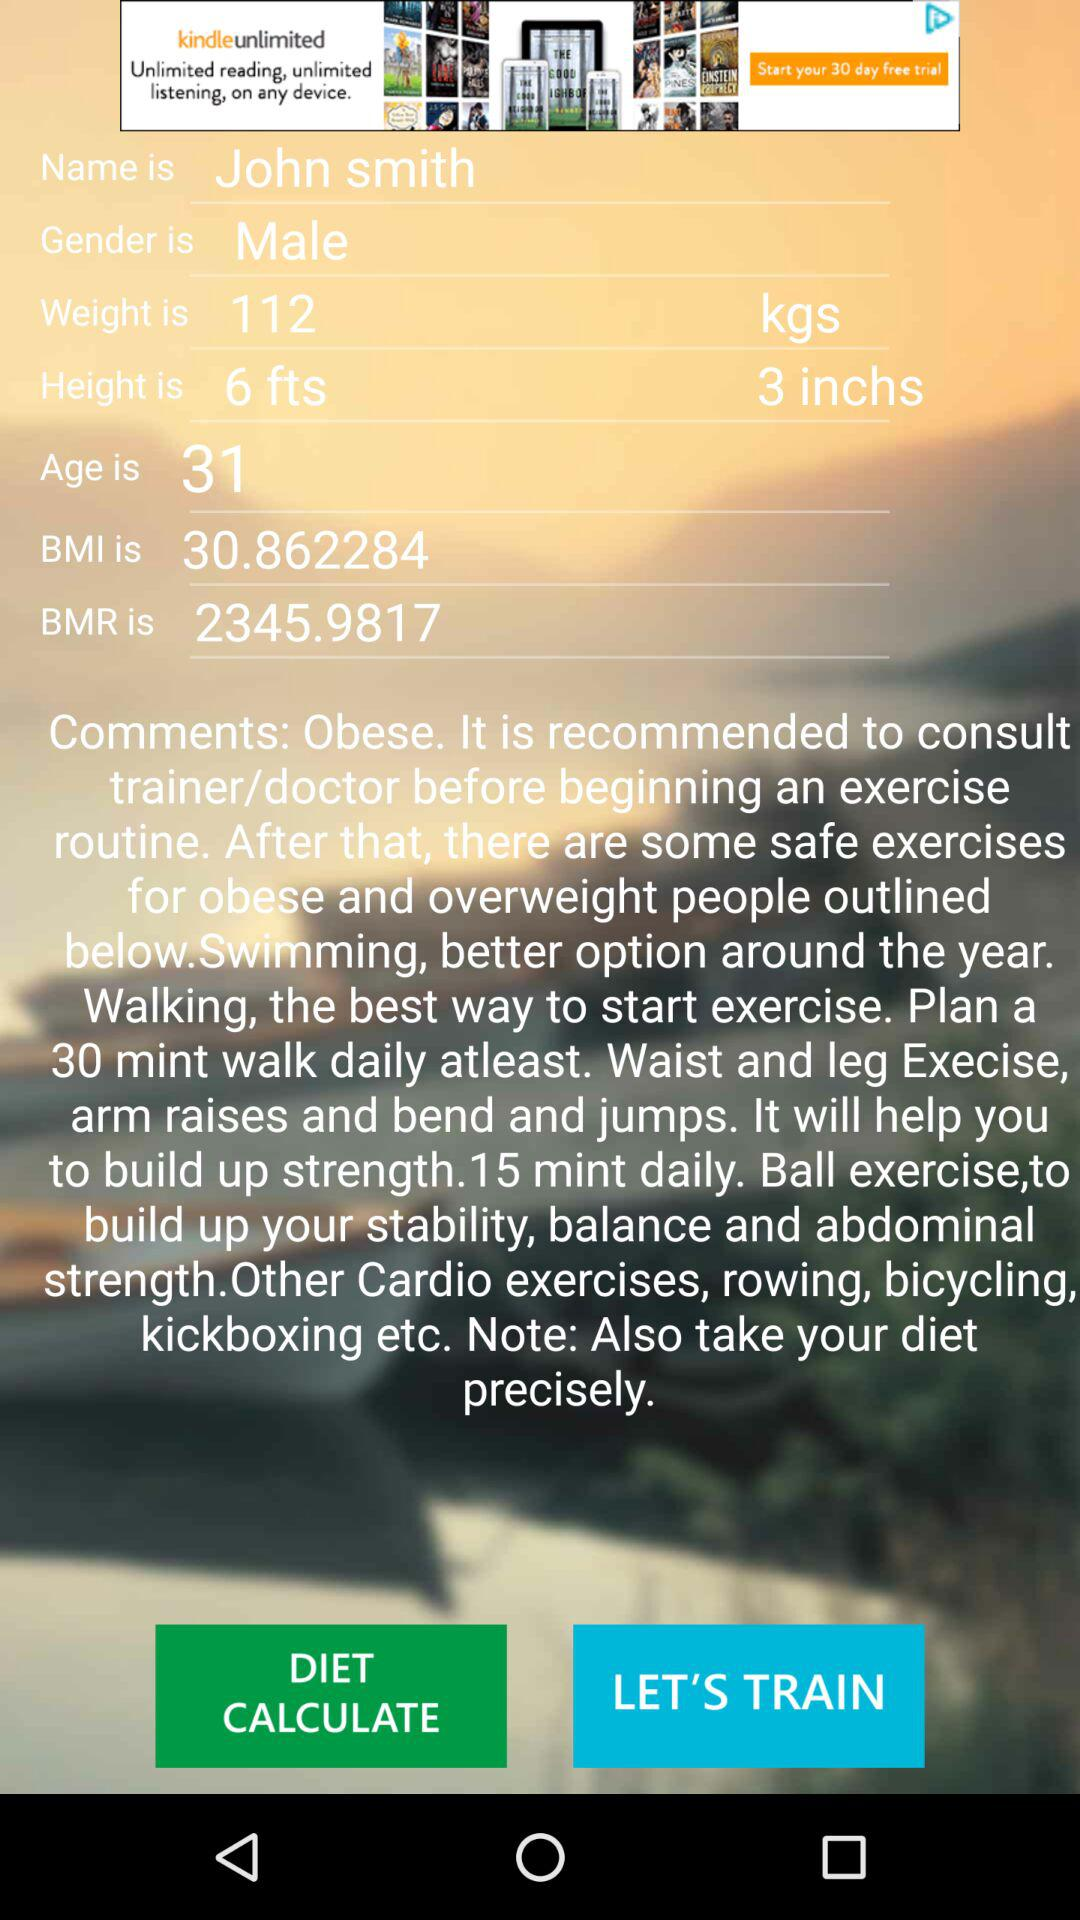What is the name? The name is John Smith. 